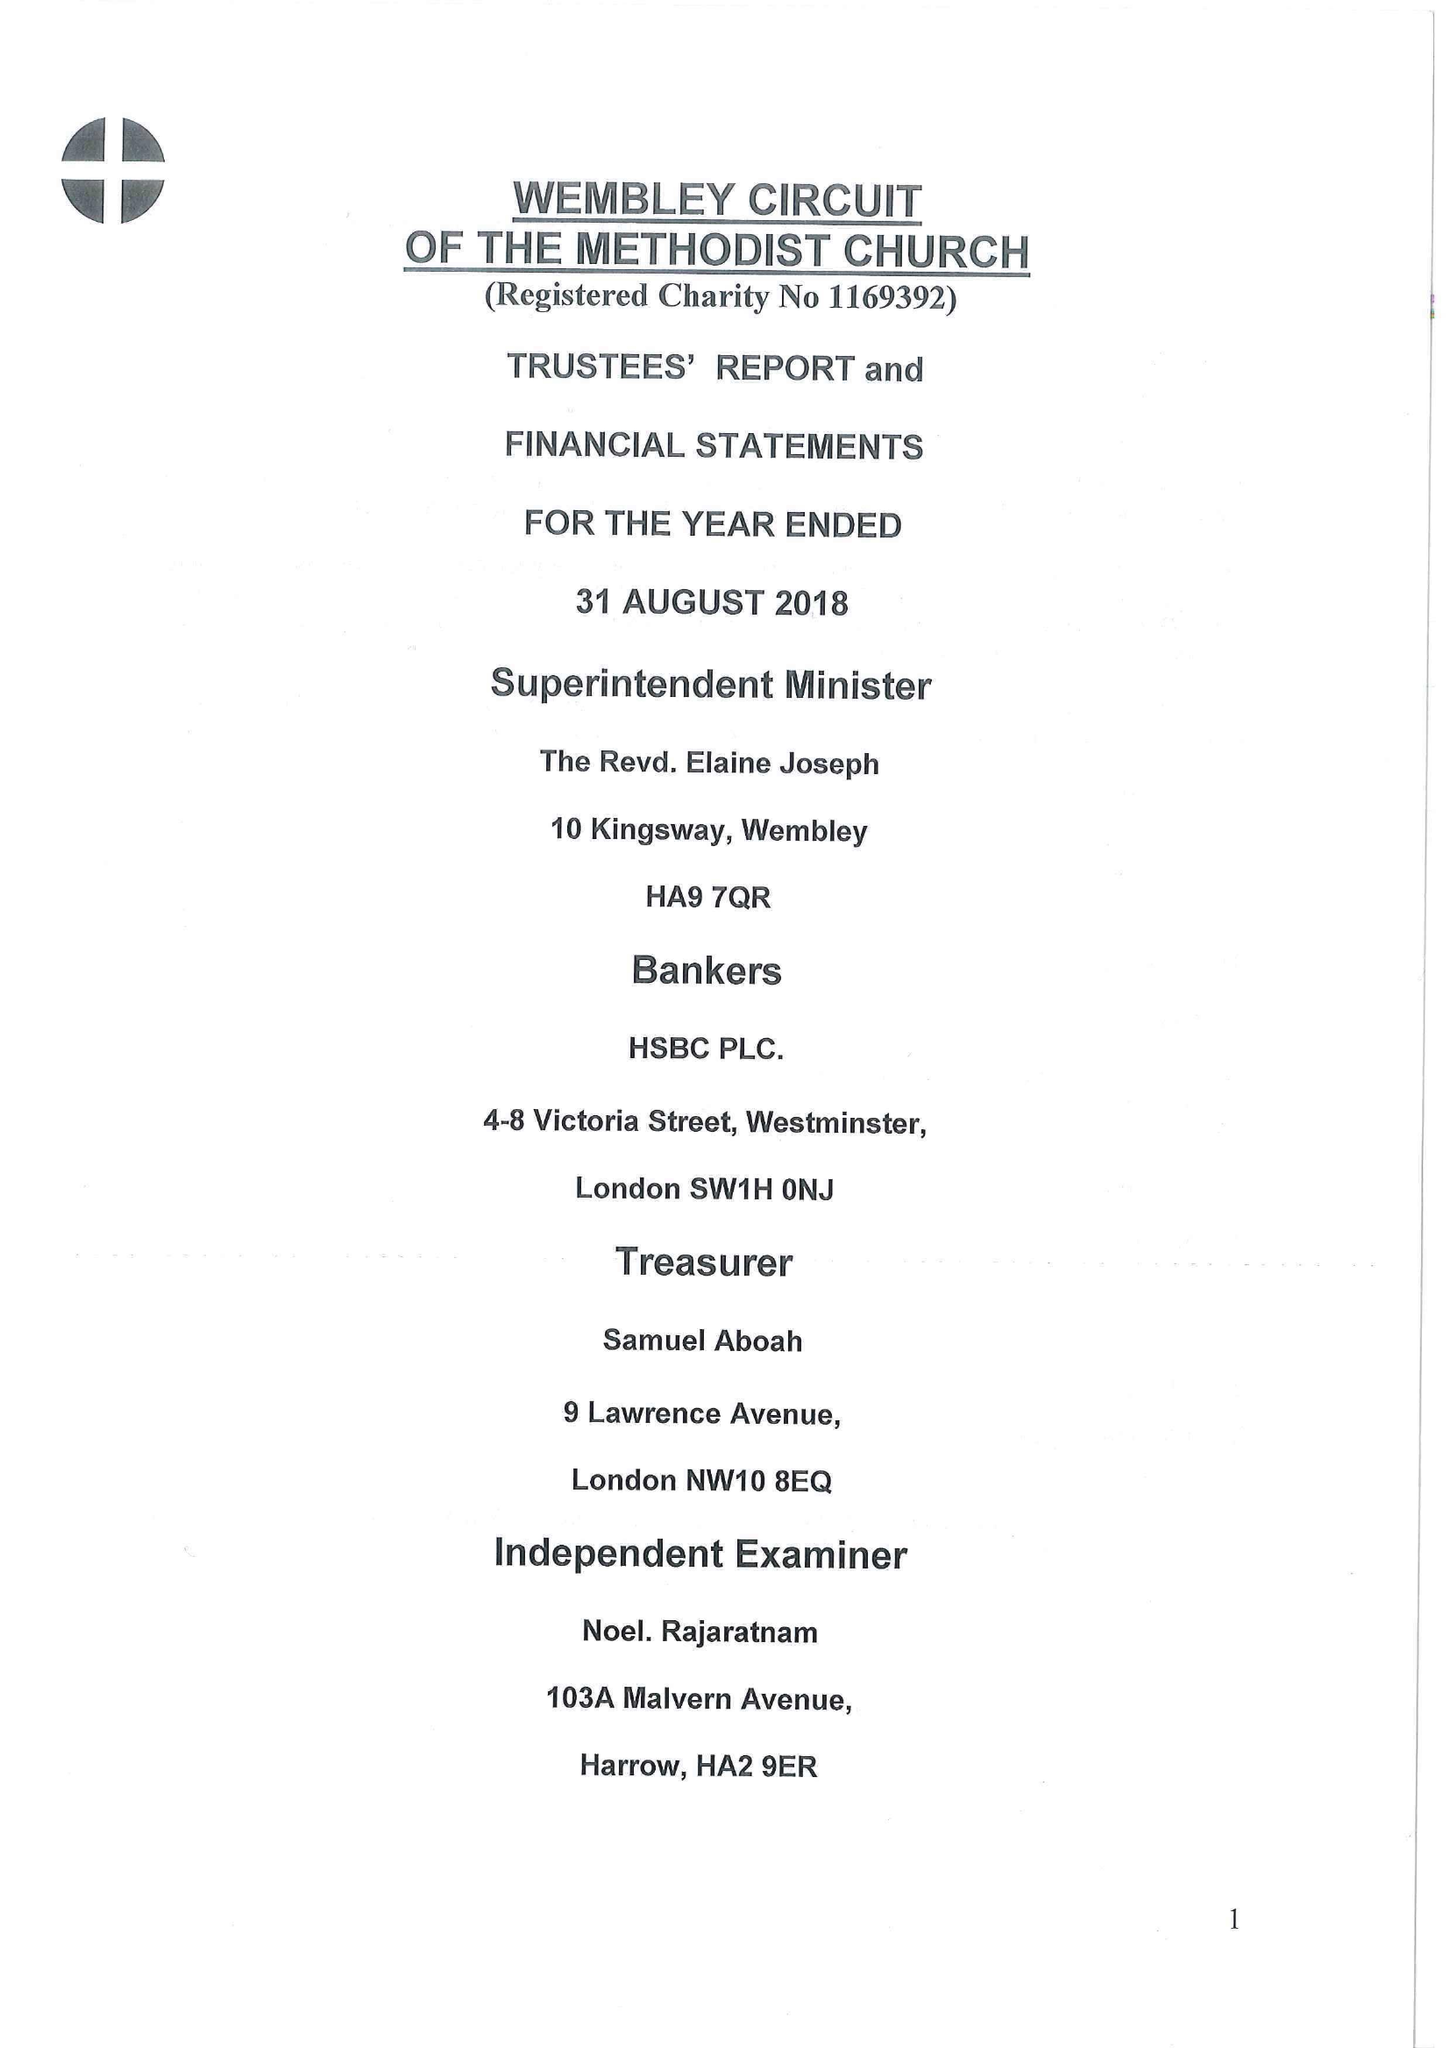What is the value for the charity_name?
Answer the question using a single word or phrase. Wembley Circuit Of The Methodist Church 